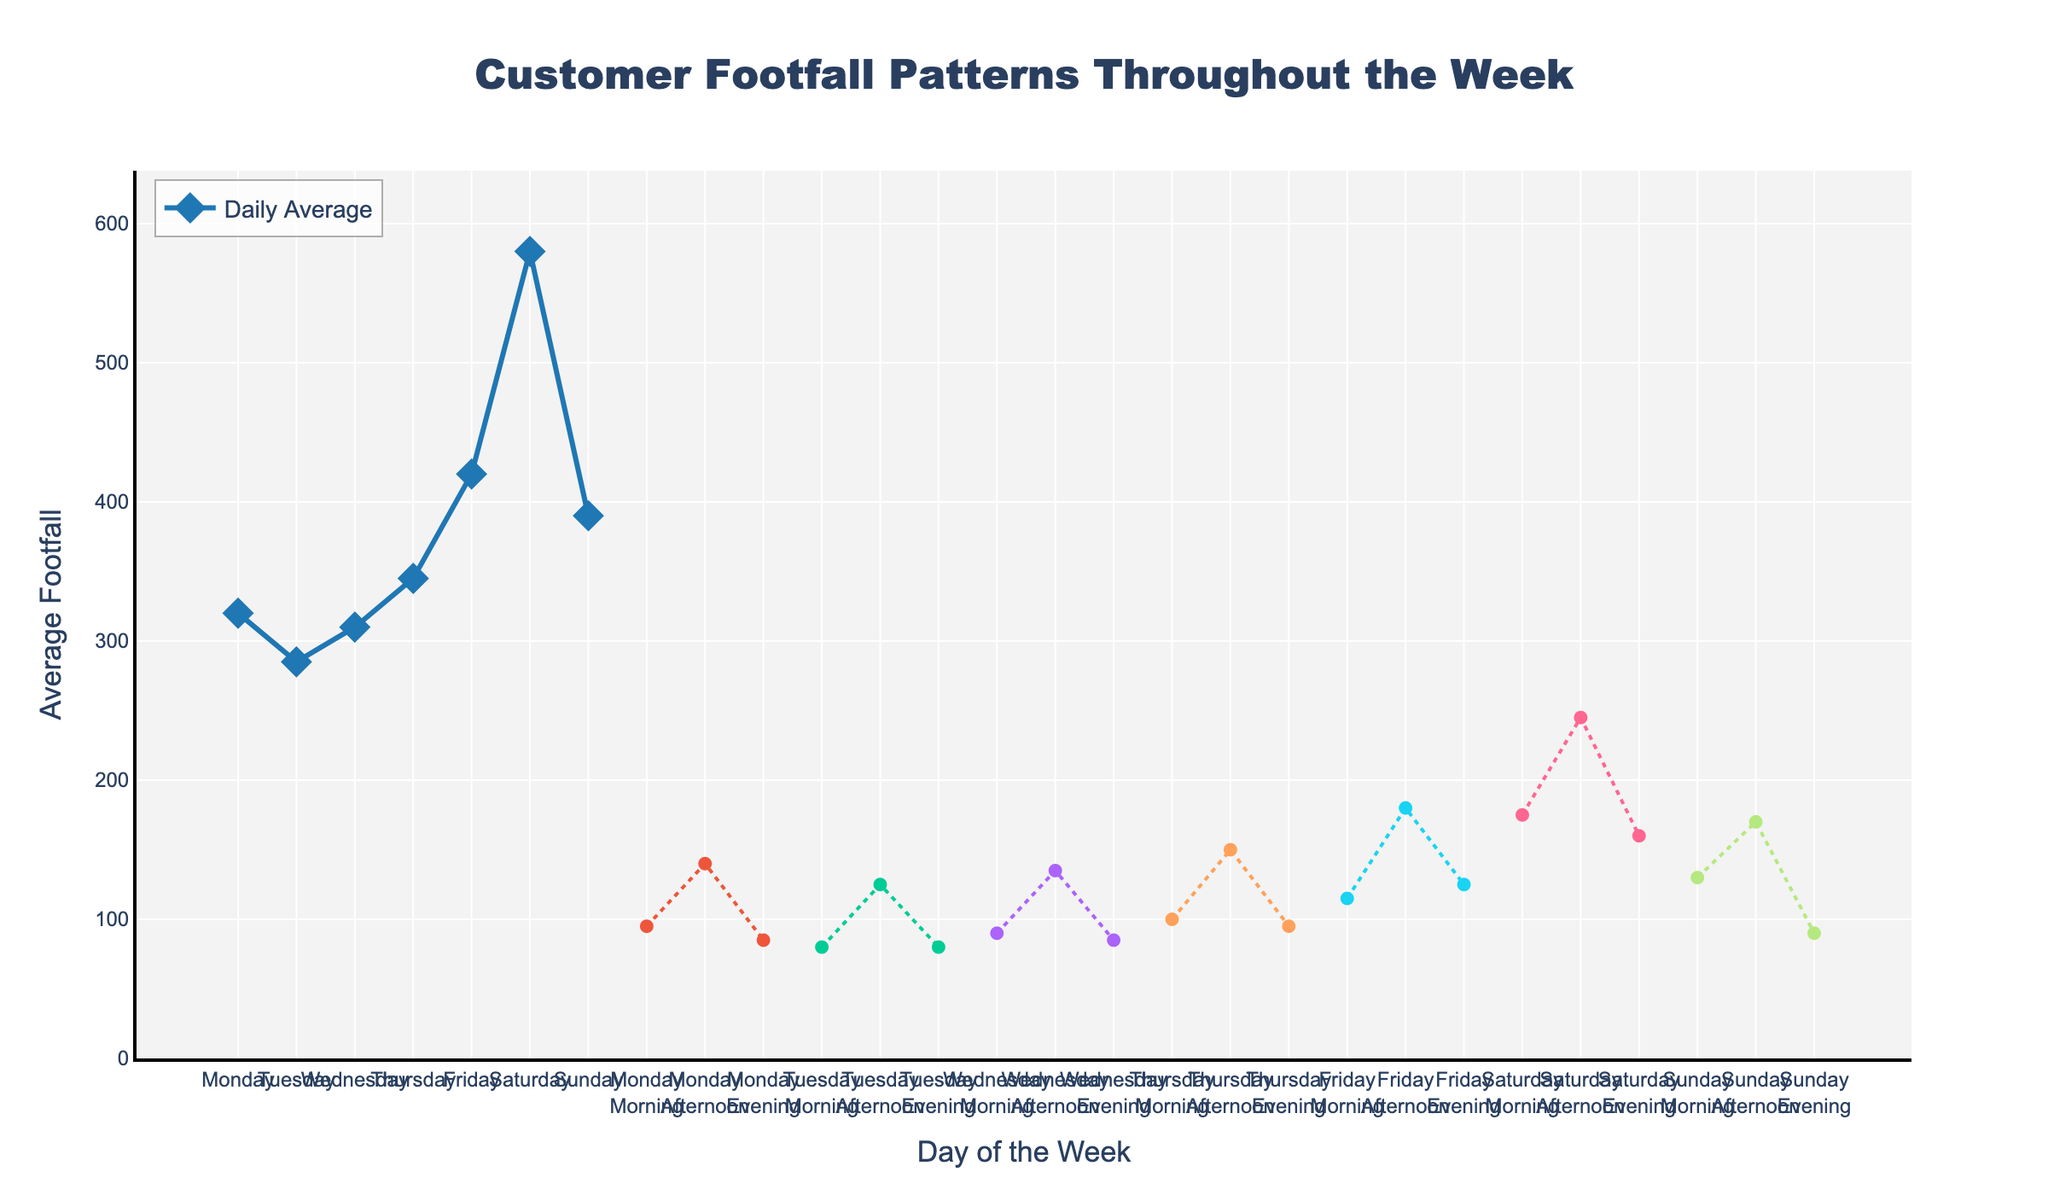Which day has the highest average footfall? The figure shows average footfall across different days. By observing the height of the lines and markers, Saturday has the highest average footfall compared to other days.
Answer: Saturday Compare the average footfall for Saturday and Monday. Which day has a higher footfall and by how much? The average footfall for Saturday is 580, and for Monday, it is 320. Calculate the difference: 580 - 320.
Answer: Saturday by 260 What is the average footfall for weekday evenings (Monday to Friday)? Identify the evening footfall for each weekday: Monday (85), Tuesday (80), Wednesday (85), Thursday (95), and Friday (125). Calculate the average: (85 + 80 + 85 + 95 + 125) / 5.
Answer: 94 Which time period, Saturday afternoon or Sunday afternoon, has a higher average footfall and by how much? The average footfall for Saturday afternoon is 245, and for Sunday afternoon, it is 170. Calculate the difference: 245 - 170.
Answer: Saturday afternoon by 75 Rank the average footfall from highest to lowest for different parts of the day on Friday. The figure shows footfall for Friday divided into morning (115), afternoon (180), and evening (125). Order these: 180, 125, 115.
Answer: Afternoon, Evening, Morning What visual attribute indicates the daily average footfall trend in the figure? The daily average footfall is represented by a solid line with diamond markers. The line's height and marker positions indicate the footfall values.
Answer: Height of the line with diamond markers Compare the average footfall for Monday morning and Monday afternoon. Which period has a higher footfall and by how much? The average footfall for Monday morning is 95, and for Monday afternoon, it is 140. Calculate the difference: 140 - 95.
Answer: Monday afternoon by 45 Which part of the week (Wednesday or Thursday) shows a higher average footfall in the afternoon? The figure shows the afternoon average footfall for Wednesday (135) and Thursday (150). Compare these values.
Answer: Thursday What is the total average footfall for Friday throughout the day? Look at the average footfall values for Friday: Morning (115), Afternoon (180), and Evening (125). Sum them up: 115 + 180 + 125.
Answer: 420 What appears to be the trend in customer footfall from Monday to Sunday? Observing the lines and markers from Monday to Sunday, footfall seems to increase steadily, peaking on Saturday, and showing a slight decrease on Sunday.
Answer: Increasing trend peaking on Saturday 